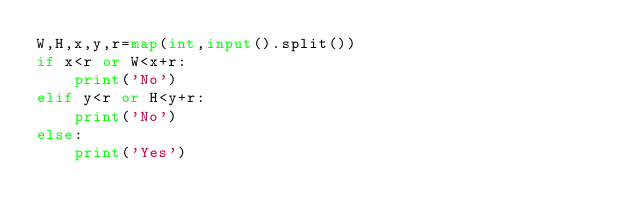<code> <loc_0><loc_0><loc_500><loc_500><_Python_>W,H,x,y,r=map(int,input().split())
if x<r or W<x+r:
    print('No')
elif y<r or H<y+r:
    print('No')
else:
    print('Yes')
</code> 